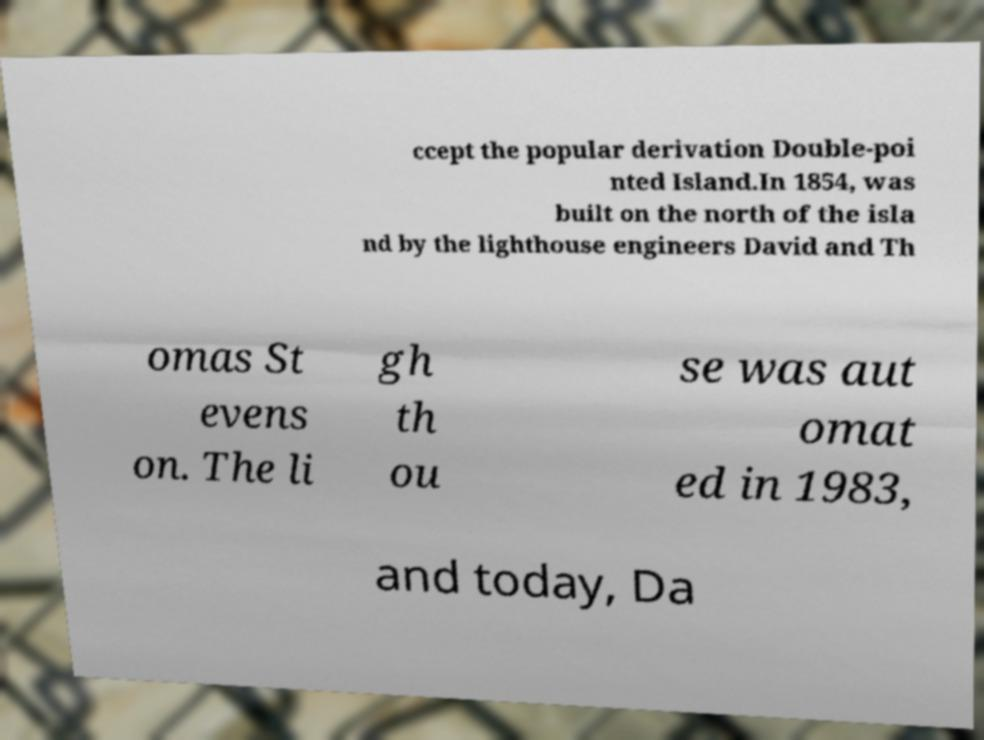For documentation purposes, I need the text within this image transcribed. Could you provide that? ccept the popular derivation Double-poi nted Island.In 1854, was built on the north of the isla nd by the lighthouse engineers David and Th omas St evens on. The li gh th ou se was aut omat ed in 1983, and today, Da 